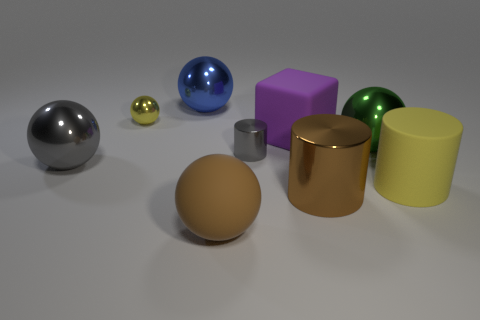Subtract all purple balls. Subtract all yellow cylinders. How many balls are left? 5 Subtract all cylinders. How many objects are left? 6 Add 1 tiny balls. How many tiny balls are left? 2 Add 4 large matte balls. How many large matte balls exist? 5 Subtract 0 yellow cubes. How many objects are left? 9 Subtract all big matte cubes. Subtract all large matte balls. How many objects are left? 7 